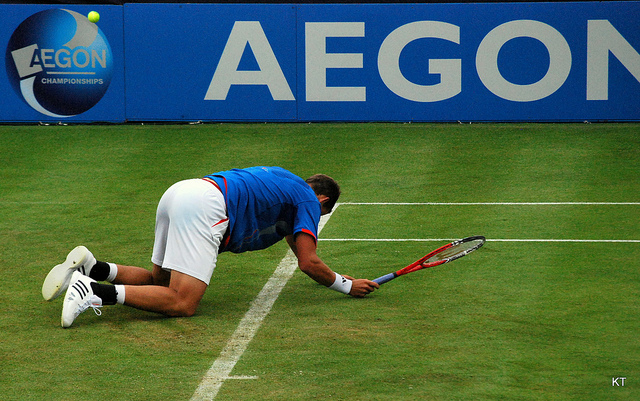Identify the text displayed in this image. AEGON CHAMPIONSHIPS AEGON KT 3 